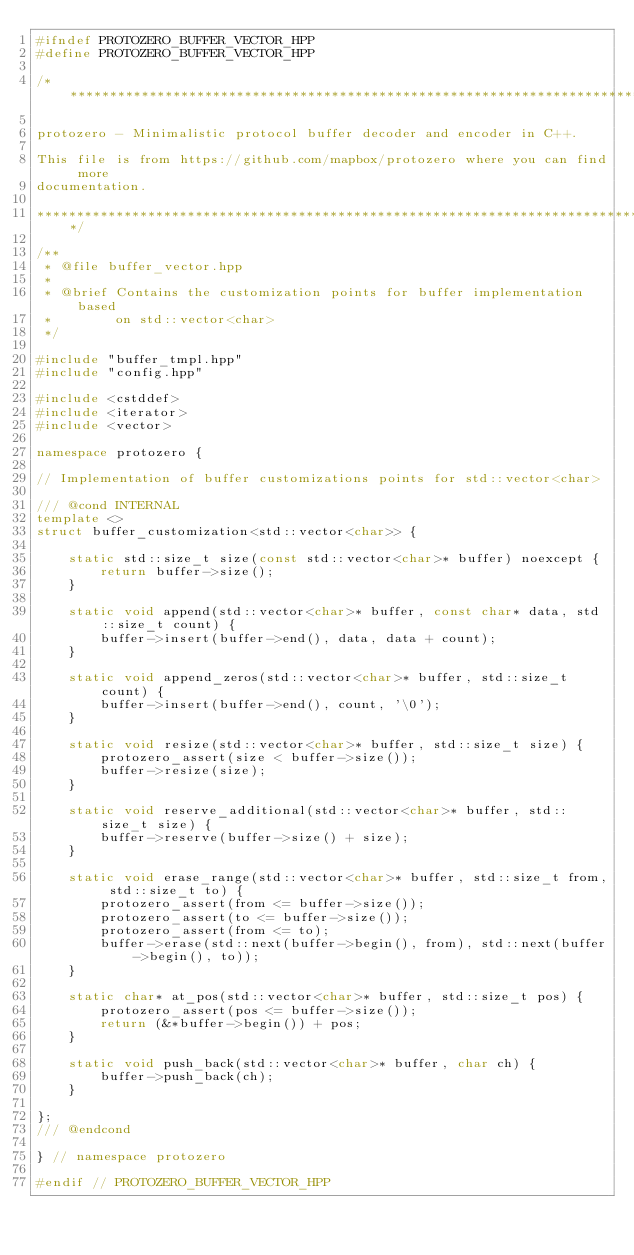Convert code to text. <code><loc_0><loc_0><loc_500><loc_500><_C++_>#ifndef PROTOZERO_BUFFER_VECTOR_HPP
#define PROTOZERO_BUFFER_VECTOR_HPP

/*****************************************************************************

protozero - Minimalistic protocol buffer decoder and encoder in C++.

This file is from https://github.com/mapbox/protozero where you can find more
documentation.

*****************************************************************************/

/**
 * @file buffer_vector.hpp
 *
 * @brief Contains the customization points for buffer implementation based
 *        on std::vector<char>
 */

#include "buffer_tmpl.hpp"
#include "config.hpp"

#include <cstddef>
#include <iterator>
#include <vector>

namespace protozero {

// Implementation of buffer customizations points for std::vector<char>

/// @cond INTERNAL
template <>
struct buffer_customization<std::vector<char>> {

    static std::size_t size(const std::vector<char>* buffer) noexcept {
        return buffer->size();
    }

    static void append(std::vector<char>* buffer, const char* data, std::size_t count) {
        buffer->insert(buffer->end(), data, data + count);
    }

    static void append_zeros(std::vector<char>* buffer, std::size_t count) {
        buffer->insert(buffer->end(), count, '\0');
    }

    static void resize(std::vector<char>* buffer, std::size_t size) {
        protozero_assert(size < buffer->size());
        buffer->resize(size);
    }

    static void reserve_additional(std::vector<char>* buffer, std::size_t size) {
        buffer->reserve(buffer->size() + size);
    }

    static void erase_range(std::vector<char>* buffer, std::size_t from, std::size_t to) {
        protozero_assert(from <= buffer->size());
        protozero_assert(to <= buffer->size());
        protozero_assert(from <= to);
        buffer->erase(std::next(buffer->begin(), from), std::next(buffer->begin(), to));
    }

    static char* at_pos(std::vector<char>* buffer, std::size_t pos) {
        protozero_assert(pos <= buffer->size());
        return (&*buffer->begin()) + pos;
    }

    static void push_back(std::vector<char>* buffer, char ch) {
        buffer->push_back(ch);
    }

};
/// @endcond

} // namespace protozero

#endif // PROTOZERO_BUFFER_VECTOR_HPP
</code> 